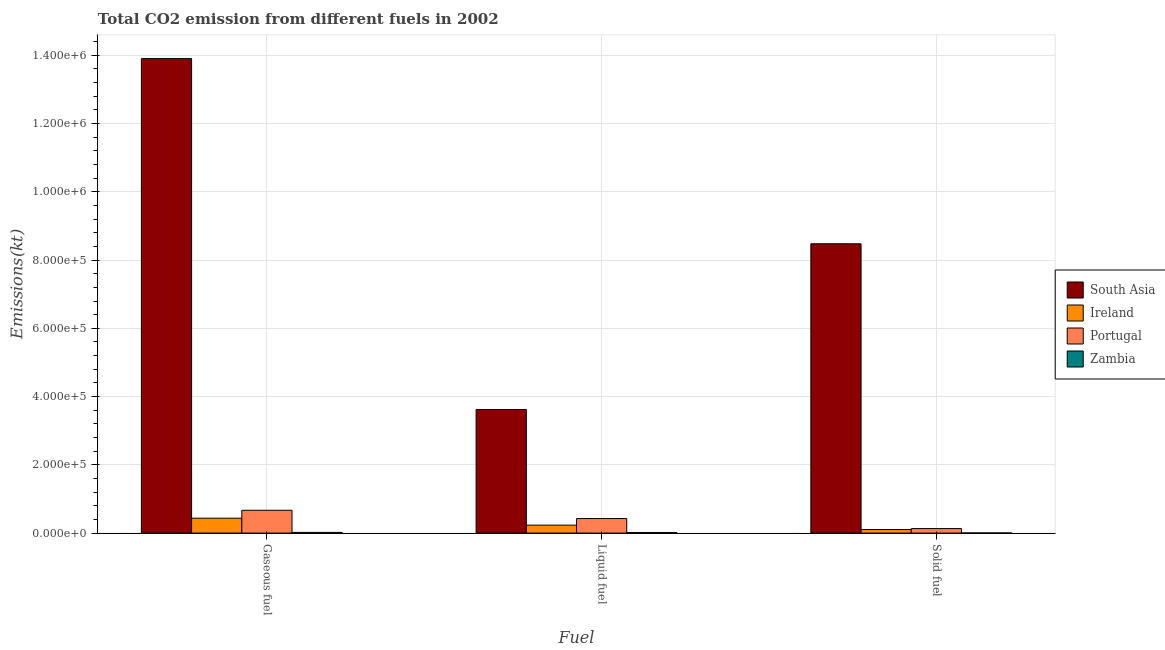How many groups of bars are there?
Ensure brevity in your answer.  3. What is the label of the 1st group of bars from the left?
Provide a short and direct response. Gaseous fuel. What is the amount of co2 emissions from gaseous fuel in Ireland?
Ensure brevity in your answer.  4.36e+04. Across all countries, what is the maximum amount of co2 emissions from solid fuel?
Offer a very short reply. 8.48e+05. Across all countries, what is the minimum amount of co2 emissions from solid fuel?
Give a very brief answer. 304.36. In which country was the amount of co2 emissions from solid fuel minimum?
Keep it short and to the point. Zambia. What is the total amount of co2 emissions from liquid fuel in the graph?
Your response must be concise. 4.29e+05. What is the difference between the amount of co2 emissions from solid fuel in Zambia and that in Portugal?
Provide a succinct answer. -1.29e+04. What is the difference between the amount of co2 emissions from gaseous fuel in South Asia and the amount of co2 emissions from liquid fuel in Portugal?
Your answer should be compact. 1.35e+06. What is the average amount of co2 emissions from solid fuel per country?
Offer a terse response. 2.18e+05. What is the difference between the amount of co2 emissions from liquid fuel and amount of co2 emissions from gaseous fuel in Ireland?
Keep it short and to the point. -2.04e+04. What is the ratio of the amount of co2 emissions from gaseous fuel in Portugal to that in Zambia?
Your answer should be very brief. 33.93. Is the amount of co2 emissions from liquid fuel in Zambia less than that in South Asia?
Offer a terse response. Yes. Is the difference between the amount of co2 emissions from gaseous fuel in Portugal and South Asia greater than the difference between the amount of co2 emissions from solid fuel in Portugal and South Asia?
Keep it short and to the point. No. What is the difference between the highest and the second highest amount of co2 emissions from liquid fuel?
Provide a succinct answer. 3.20e+05. What is the difference between the highest and the lowest amount of co2 emissions from solid fuel?
Give a very brief answer. 8.47e+05. What does the 2nd bar from the left in Gaseous fuel represents?
Provide a succinct answer. Ireland. What does the 4th bar from the right in Liquid fuel represents?
Provide a short and direct response. South Asia. What is the difference between two consecutive major ticks on the Y-axis?
Ensure brevity in your answer.  2.00e+05. Does the graph contain any zero values?
Keep it short and to the point. No. Does the graph contain grids?
Keep it short and to the point. Yes. How many legend labels are there?
Provide a short and direct response. 4. How are the legend labels stacked?
Make the answer very short. Vertical. What is the title of the graph?
Your response must be concise. Total CO2 emission from different fuels in 2002. What is the label or title of the X-axis?
Provide a short and direct response. Fuel. What is the label or title of the Y-axis?
Keep it short and to the point. Emissions(kt). What is the Emissions(kt) of South Asia in Gaseous fuel?
Offer a terse response. 1.39e+06. What is the Emissions(kt) in Ireland in Gaseous fuel?
Keep it short and to the point. 4.36e+04. What is the Emissions(kt) in Portugal in Gaseous fuel?
Your answer should be compact. 6.68e+04. What is the Emissions(kt) in Zambia in Gaseous fuel?
Your answer should be compact. 1969.18. What is the Emissions(kt) of South Asia in Liquid fuel?
Your response must be concise. 3.62e+05. What is the Emissions(kt) in Ireland in Liquid fuel?
Your answer should be compact. 2.32e+04. What is the Emissions(kt) in Portugal in Liquid fuel?
Provide a succinct answer. 4.25e+04. What is the Emissions(kt) of Zambia in Liquid fuel?
Your answer should be very brief. 1551.14. What is the Emissions(kt) in South Asia in Solid fuel?
Keep it short and to the point. 8.48e+05. What is the Emissions(kt) of Ireland in Solid fuel?
Ensure brevity in your answer.  1.03e+04. What is the Emissions(kt) of Portugal in Solid fuel?
Offer a very short reply. 1.32e+04. What is the Emissions(kt) of Zambia in Solid fuel?
Your answer should be very brief. 304.36. Across all Fuel, what is the maximum Emissions(kt) in South Asia?
Make the answer very short. 1.39e+06. Across all Fuel, what is the maximum Emissions(kt) of Ireland?
Provide a succinct answer. 4.36e+04. Across all Fuel, what is the maximum Emissions(kt) of Portugal?
Make the answer very short. 6.68e+04. Across all Fuel, what is the maximum Emissions(kt) of Zambia?
Make the answer very short. 1969.18. Across all Fuel, what is the minimum Emissions(kt) of South Asia?
Provide a short and direct response. 3.62e+05. Across all Fuel, what is the minimum Emissions(kt) in Ireland?
Your answer should be compact. 1.03e+04. Across all Fuel, what is the minimum Emissions(kt) in Portugal?
Give a very brief answer. 1.32e+04. Across all Fuel, what is the minimum Emissions(kt) in Zambia?
Keep it short and to the point. 304.36. What is the total Emissions(kt) in South Asia in the graph?
Provide a short and direct response. 2.60e+06. What is the total Emissions(kt) in Ireland in the graph?
Provide a short and direct response. 7.72e+04. What is the total Emissions(kt) in Portugal in the graph?
Make the answer very short. 1.23e+05. What is the total Emissions(kt) in Zambia in the graph?
Give a very brief answer. 3824.68. What is the difference between the Emissions(kt) of South Asia in Gaseous fuel and that in Liquid fuel?
Ensure brevity in your answer.  1.03e+06. What is the difference between the Emissions(kt) in Ireland in Gaseous fuel and that in Liquid fuel?
Ensure brevity in your answer.  2.04e+04. What is the difference between the Emissions(kt) in Portugal in Gaseous fuel and that in Liquid fuel?
Your answer should be compact. 2.43e+04. What is the difference between the Emissions(kt) of Zambia in Gaseous fuel and that in Liquid fuel?
Offer a terse response. 418.04. What is the difference between the Emissions(kt) in South Asia in Gaseous fuel and that in Solid fuel?
Provide a succinct answer. 5.43e+05. What is the difference between the Emissions(kt) in Ireland in Gaseous fuel and that in Solid fuel?
Provide a short and direct response. 3.33e+04. What is the difference between the Emissions(kt) of Portugal in Gaseous fuel and that in Solid fuel?
Provide a short and direct response. 5.36e+04. What is the difference between the Emissions(kt) of Zambia in Gaseous fuel and that in Solid fuel?
Give a very brief answer. 1664.82. What is the difference between the Emissions(kt) of South Asia in Liquid fuel and that in Solid fuel?
Provide a succinct answer. -4.86e+05. What is the difference between the Emissions(kt) in Ireland in Liquid fuel and that in Solid fuel?
Make the answer very short. 1.29e+04. What is the difference between the Emissions(kt) in Portugal in Liquid fuel and that in Solid fuel?
Make the answer very short. 2.93e+04. What is the difference between the Emissions(kt) in Zambia in Liquid fuel and that in Solid fuel?
Provide a short and direct response. 1246.78. What is the difference between the Emissions(kt) in South Asia in Gaseous fuel and the Emissions(kt) in Ireland in Liquid fuel?
Your response must be concise. 1.37e+06. What is the difference between the Emissions(kt) in South Asia in Gaseous fuel and the Emissions(kt) in Portugal in Liquid fuel?
Your answer should be very brief. 1.35e+06. What is the difference between the Emissions(kt) in South Asia in Gaseous fuel and the Emissions(kt) in Zambia in Liquid fuel?
Make the answer very short. 1.39e+06. What is the difference between the Emissions(kt) of Ireland in Gaseous fuel and the Emissions(kt) of Portugal in Liquid fuel?
Offer a terse response. 1100.1. What is the difference between the Emissions(kt) in Ireland in Gaseous fuel and the Emissions(kt) in Zambia in Liquid fuel?
Offer a very short reply. 4.21e+04. What is the difference between the Emissions(kt) in Portugal in Gaseous fuel and the Emissions(kt) in Zambia in Liquid fuel?
Keep it short and to the point. 6.53e+04. What is the difference between the Emissions(kt) in South Asia in Gaseous fuel and the Emissions(kt) in Ireland in Solid fuel?
Offer a very short reply. 1.38e+06. What is the difference between the Emissions(kt) in South Asia in Gaseous fuel and the Emissions(kt) in Portugal in Solid fuel?
Ensure brevity in your answer.  1.38e+06. What is the difference between the Emissions(kt) of South Asia in Gaseous fuel and the Emissions(kt) of Zambia in Solid fuel?
Give a very brief answer. 1.39e+06. What is the difference between the Emissions(kt) in Ireland in Gaseous fuel and the Emissions(kt) in Portugal in Solid fuel?
Your response must be concise. 3.04e+04. What is the difference between the Emissions(kt) in Ireland in Gaseous fuel and the Emissions(kt) in Zambia in Solid fuel?
Give a very brief answer. 4.33e+04. What is the difference between the Emissions(kt) of Portugal in Gaseous fuel and the Emissions(kt) of Zambia in Solid fuel?
Give a very brief answer. 6.65e+04. What is the difference between the Emissions(kt) in South Asia in Liquid fuel and the Emissions(kt) in Ireland in Solid fuel?
Provide a succinct answer. 3.52e+05. What is the difference between the Emissions(kt) of South Asia in Liquid fuel and the Emissions(kt) of Portugal in Solid fuel?
Give a very brief answer. 3.49e+05. What is the difference between the Emissions(kt) in South Asia in Liquid fuel and the Emissions(kt) in Zambia in Solid fuel?
Your answer should be compact. 3.62e+05. What is the difference between the Emissions(kt) in Ireland in Liquid fuel and the Emissions(kt) in Portugal in Solid fuel?
Make the answer very short. 1.00e+04. What is the difference between the Emissions(kt) in Ireland in Liquid fuel and the Emissions(kt) in Zambia in Solid fuel?
Your answer should be very brief. 2.29e+04. What is the difference between the Emissions(kt) of Portugal in Liquid fuel and the Emissions(kt) of Zambia in Solid fuel?
Keep it short and to the point. 4.22e+04. What is the average Emissions(kt) in South Asia per Fuel?
Make the answer very short. 8.67e+05. What is the average Emissions(kt) of Ireland per Fuel?
Ensure brevity in your answer.  2.57e+04. What is the average Emissions(kt) in Portugal per Fuel?
Keep it short and to the point. 4.08e+04. What is the average Emissions(kt) of Zambia per Fuel?
Make the answer very short. 1274.89. What is the difference between the Emissions(kt) in South Asia and Emissions(kt) in Ireland in Gaseous fuel?
Your answer should be very brief. 1.35e+06. What is the difference between the Emissions(kt) in South Asia and Emissions(kt) in Portugal in Gaseous fuel?
Offer a very short reply. 1.32e+06. What is the difference between the Emissions(kt) in South Asia and Emissions(kt) in Zambia in Gaseous fuel?
Ensure brevity in your answer.  1.39e+06. What is the difference between the Emissions(kt) in Ireland and Emissions(kt) in Portugal in Gaseous fuel?
Keep it short and to the point. -2.32e+04. What is the difference between the Emissions(kt) of Ireland and Emissions(kt) of Zambia in Gaseous fuel?
Your answer should be compact. 4.16e+04. What is the difference between the Emissions(kt) of Portugal and Emissions(kt) of Zambia in Gaseous fuel?
Provide a short and direct response. 6.49e+04. What is the difference between the Emissions(kt) of South Asia and Emissions(kt) of Ireland in Liquid fuel?
Offer a very short reply. 3.39e+05. What is the difference between the Emissions(kt) of South Asia and Emissions(kt) of Portugal in Liquid fuel?
Your response must be concise. 3.20e+05. What is the difference between the Emissions(kt) of South Asia and Emissions(kt) of Zambia in Liquid fuel?
Give a very brief answer. 3.61e+05. What is the difference between the Emissions(kt) in Ireland and Emissions(kt) in Portugal in Liquid fuel?
Keep it short and to the point. -1.93e+04. What is the difference between the Emissions(kt) in Ireland and Emissions(kt) in Zambia in Liquid fuel?
Ensure brevity in your answer.  2.16e+04. What is the difference between the Emissions(kt) in Portugal and Emissions(kt) in Zambia in Liquid fuel?
Provide a short and direct response. 4.10e+04. What is the difference between the Emissions(kt) in South Asia and Emissions(kt) in Ireland in Solid fuel?
Offer a very short reply. 8.37e+05. What is the difference between the Emissions(kt) of South Asia and Emissions(kt) of Portugal in Solid fuel?
Your answer should be compact. 8.35e+05. What is the difference between the Emissions(kt) of South Asia and Emissions(kt) of Zambia in Solid fuel?
Your answer should be very brief. 8.47e+05. What is the difference between the Emissions(kt) of Ireland and Emissions(kt) of Portugal in Solid fuel?
Provide a short and direct response. -2849.26. What is the difference between the Emissions(kt) of Ireland and Emissions(kt) of Zambia in Solid fuel?
Provide a short and direct response. 1.00e+04. What is the difference between the Emissions(kt) of Portugal and Emissions(kt) of Zambia in Solid fuel?
Your answer should be very brief. 1.29e+04. What is the ratio of the Emissions(kt) of South Asia in Gaseous fuel to that in Liquid fuel?
Keep it short and to the point. 3.84. What is the ratio of the Emissions(kt) in Ireland in Gaseous fuel to that in Liquid fuel?
Your answer should be very brief. 1.88. What is the ratio of the Emissions(kt) of Portugal in Gaseous fuel to that in Liquid fuel?
Keep it short and to the point. 1.57. What is the ratio of the Emissions(kt) in Zambia in Gaseous fuel to that in Liquid fuel?
Your answer should be very brief. 1.27. What is the ratio of the Emissions(kt) of South Asia in Gaseous fuel to that in Solid fuel?
Your response must be concise. 1.64. What is the ratio of the Emissions(kt) of Ireland in Gaseous fuel to that in Solid fuel?
Your answer should be compact. 4.22. What is the ratio of the Emissions(kt) in Portugal in Gaseous fuel to that in Solid fuel?
Your answer should be compact. 5.07. What is the ratio of the Emissions(kt) of Zambia in Gaseous fuel to that in Solid fuel?
Your answer should be compact. 6.47. What is the ratio of the Emissions(kt) of South Asia in Liquid fuel to that in Solid fuel?
Offer a very short reply. 0.43. What is the ratio of the Emissions(kt) of Ireland in Liquid fuel to that in Solid fuel?
Your response must be concise. 2.25. What is the ratio of the Emissions(kt) in Portugal in Liquid fuel to that in Solid fuel?
Your answer should be compact. 3.23. What is the ratio of the Emissions(kt) of Zambia in Liquid fuel to that in Solid fuel?
Offer a terse response. 5.1. What is the difference between the highest and the second highest Emissions(kt) in South Asia?
Your answer should be compact. 5.43e+05. What is the difference between the highest and the second highest Emissions(kt) of Ireland?
Make the answer very short. 2.04e+04. What is the difference between the highest and the second highest Emissions(kt) of Portugal?
Keep it short and to the point. 2.43e+04. What is the difference between the highest and the second highest Emissions(kt) in Zambia?
Make the answer very short. 418.04. What is the difference between the highest and the lowest Emissions(kt) of South Asia?
Keep it short and to the point. 1.03e+06. What is the difference between the highest and the lowest Emissions(kt) of Ireland?
Keep it short and to the point. 3.33e+04. What is the difference between the highest and the lowest Emissions(kt) of Portugal?
Your answer should be compact. 5.36e+04. What is the difference between the highest and the lowest Emissions(kt) of Zambia?
Give a very brief answer. 1664.82. 